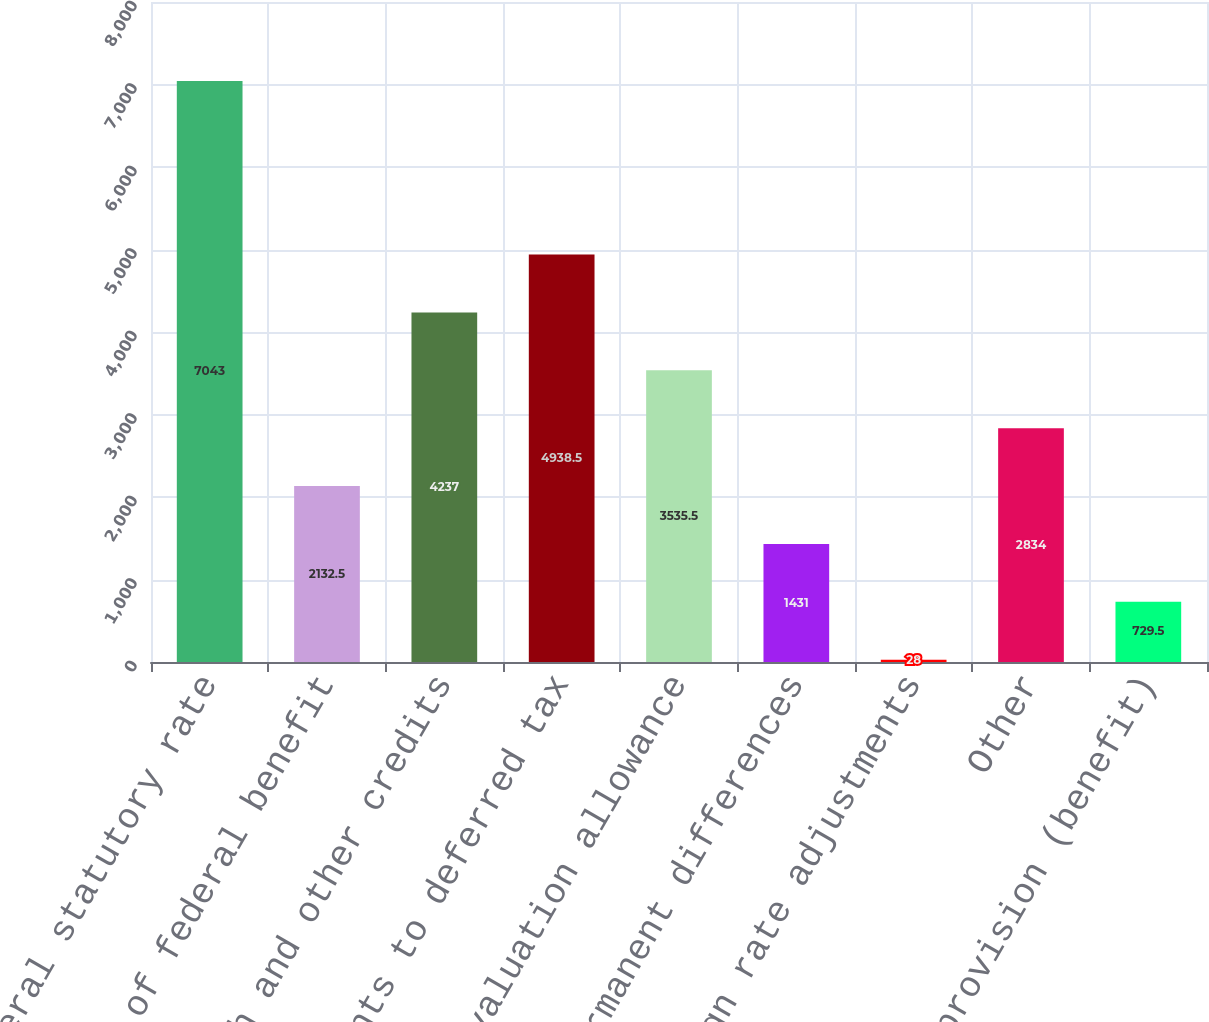<chart> <loc_0><loc_0><loc_500><loc_500><bar_chart><fcel>Tax at federal statutory rate<fcel>State net of federal benefit<fcel>Research and other credits<fcel>Adjustments to deferred tax<fcel>Change in valuation allowance<fcel>Permanent differences<fcel>Foreign rate adjustments<fcel>Other<fcel>Total tax provision (benefit)<nl><fcel>7043<fcel>2132.5<fcel>4237<fcel>4938.5<fcel>3535.5<fcel>1431<fcel>28<fcel>2834<fcel>729.5<nl></chart> 